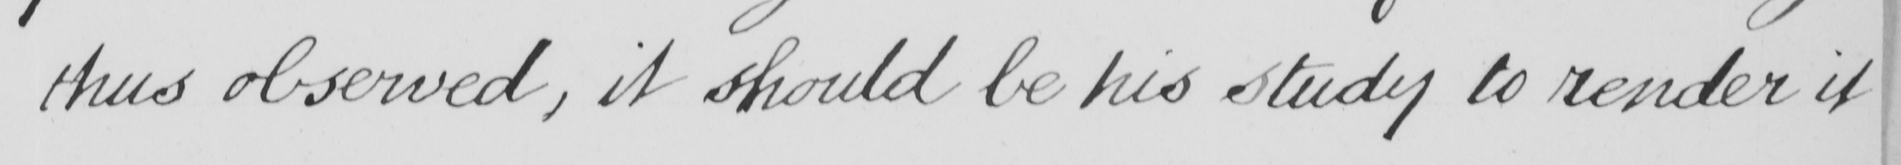Please transcribe the handwritten text in this image. thus observed , it should be his study to render it 